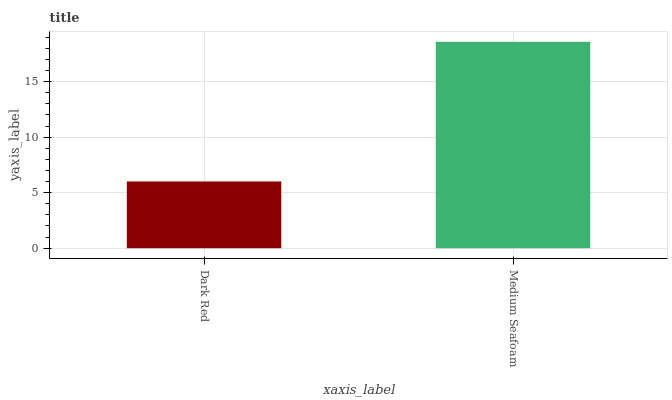Is Dark Red the minimum?
Answer yes or no. Yes. Is Medium Seafoam the maximum?
Answer yes or no. Yes. Is Medium Seafoam the minimum?
Answer yes or no. No. Is Medium Seafoam greater than Dark Red?
Answer yes or no. Yes. Is Dark Red less than Medium Seafoam?
Answer yes or no. Yes. Is Dark Red greater than Medium Seafoam?
Answer yes or no. No. Is Medium Seafoam less than Dark Red?
Answer yes or no. No. Is Medium Seafoam the high median?
Answer yes or no. Yes. Is Dark Red the low median?
Answer yes or no. Yes. Is Dark Red the high median?
Answer yes or no. No. Is Medium Seafoam the low median?
Answer yes or no. No. 